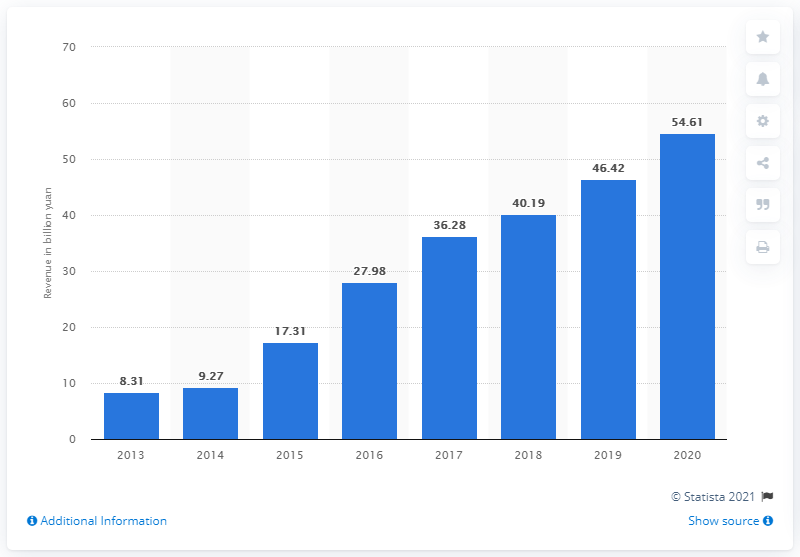Outline some significant characteristics in this image. NetEase's revenue in the previous year was 46.42... NetEase generated a revenue of 54.61 billion yuan from its online games in 2020. 